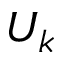Convert formula to latex. <formula><loc_0><loc_0><loc_500><loc_500>U _ { k }</formula> 